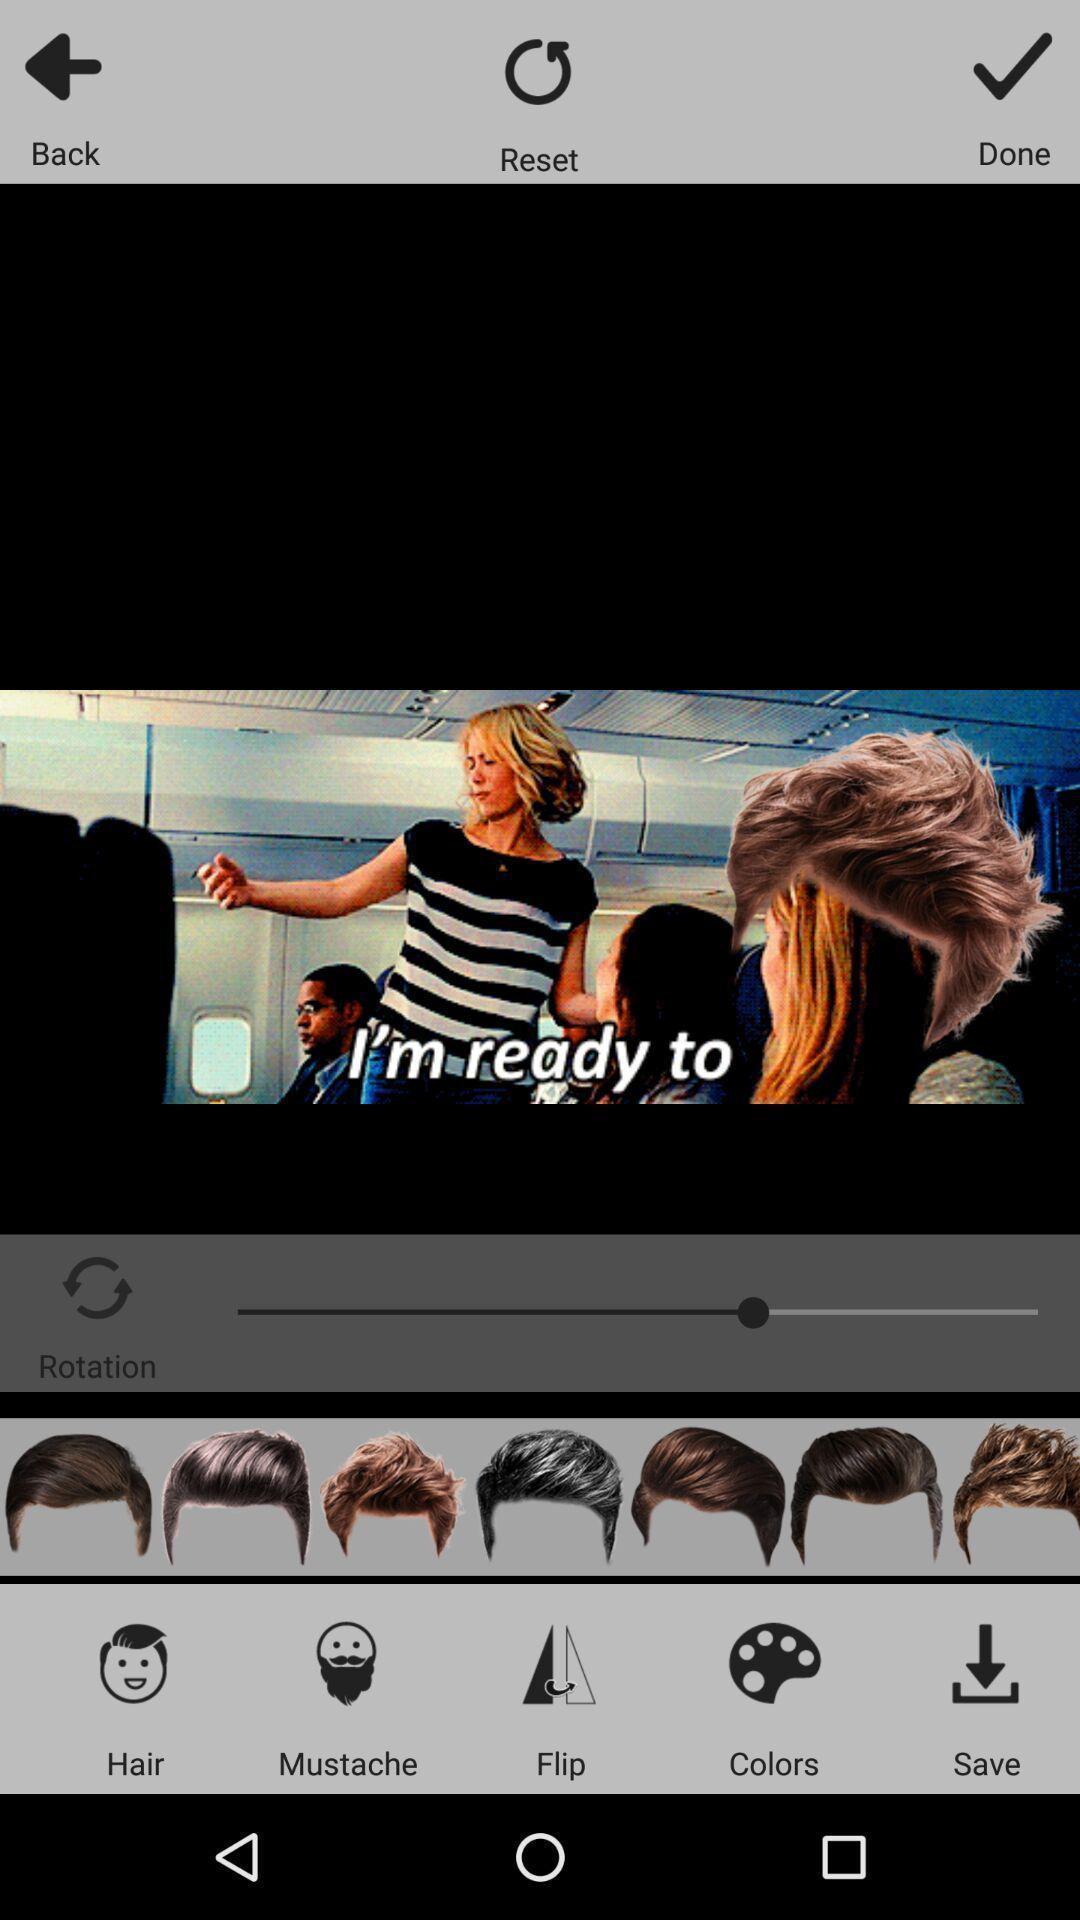Tell me what you see in this picture. Screen shows different options to edit. 